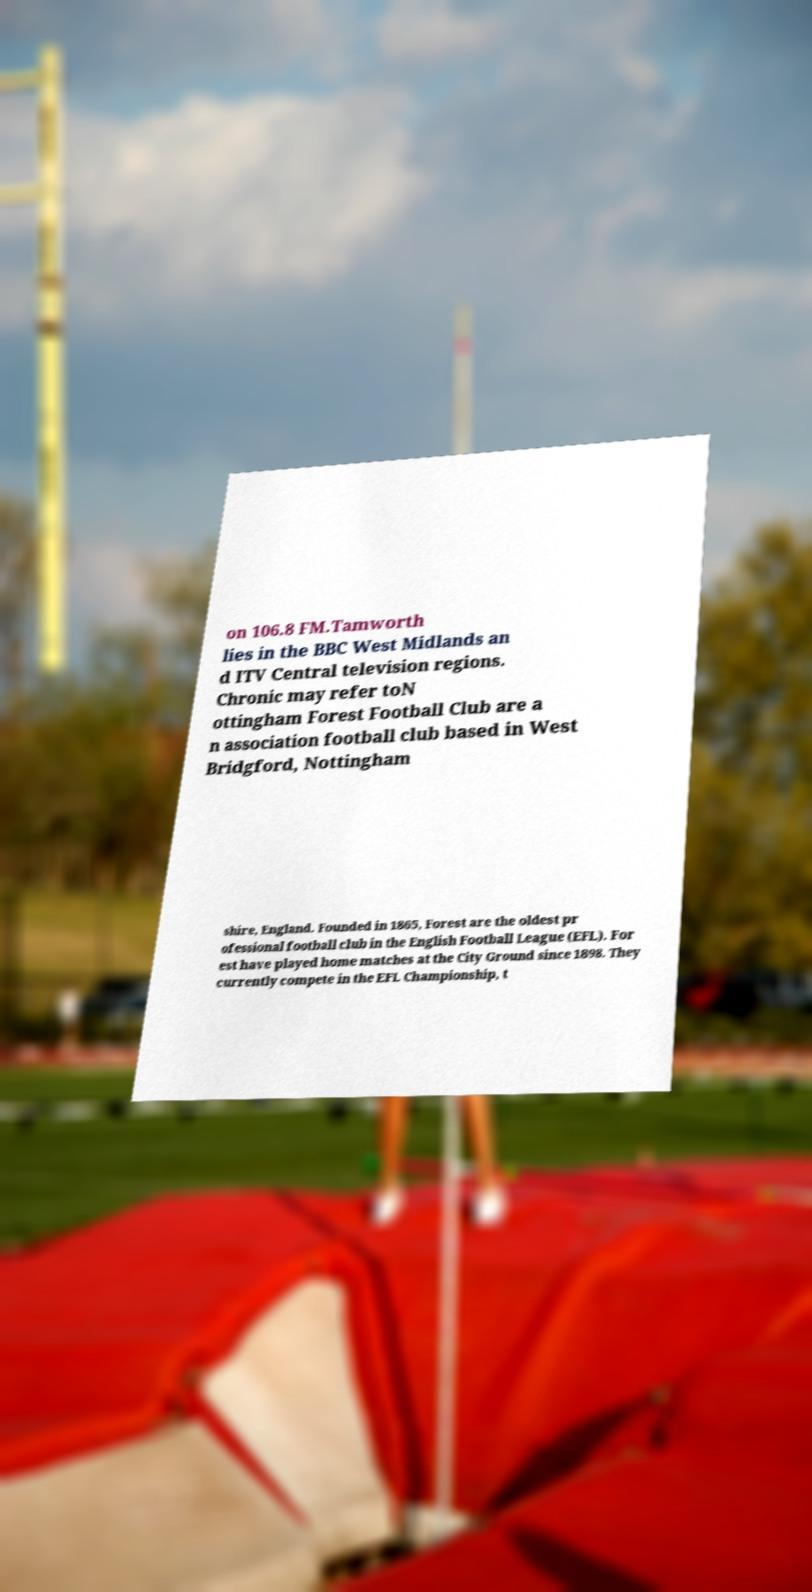There's text embedded in this image that I need extracted. Can you transcribe it verbatim? on 106.8 FM.Tamworth lies in the BBC West Midlands an d ITV Central television regions. Chronic may refer toN ottingham Forest Football Club are a n association football club based in West Bridgford, Nottingham shire, England. Founded in 1865, Forest are the oldest pr ofessional football club in the English Football League (EFL). For est have played home matches at the City Ground since 1898. They currently compete in the EFL Championship, t 